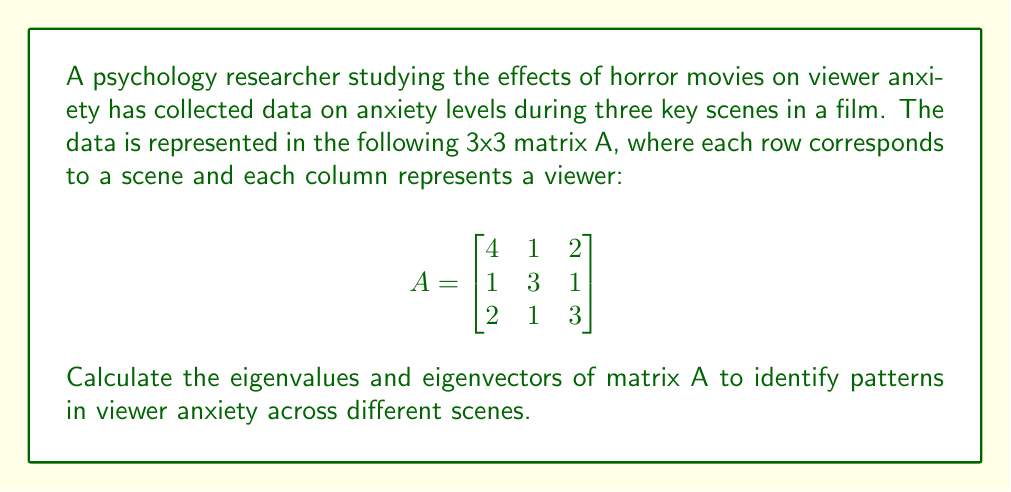Solve this math problem. To find the eigenvalues and eigenvectors of matrix A, we follow these steps:

1. Find the characteristic equation:
   $det(A - \lambda I) = 0$, where I is the 3x3 identity matrix.

   $$det\begin{pmatrix}
   4-\lambda & 1 & 2 \\
   1 & 3-\lambda & 1 \\
   2 & 1 & 3-\lambda
   \end{pmatrix} = 0$$

2. Expand the determinant:
   $(4-\lambda)[(3-\lambda)(3-\lambda)-1] - 1[1(3-\lambda)-2] + 2[1-1(3-\lambda)] = 0$
   $(4-\lambda)[(3-\lambda)^2-1] - [3-\lambda-2] + 2[1-(3-\lambda)] = 0$
   $(4-\lambda)(\lambda^2-6\lambda+8) + \lambda-1 - 2(4-\lambda) = 0$
   $4\lambda^2-24\lambda+32-\lambda^3+6\lambda^2-8\lambda+\lambda-1-8+2\lambda = 0$
   $-\lambda^3+10\lambda^2-29\lambda+23 = 0$

3. Solve the characteristic equation:
   The equation factors to: $(\lambda-1)(\lambda-3)(\lambda-6) = 0$
   So, the eigenvalues are $\lambda_1 = 1$, $\lambda_2 = 3$, and $\lambda_3 = 6$

4. Find the eigenvectors for each eigenvalue:
   For $\lambda_1 = 1$:
   Solve $(A-I)v = 0$
   $$\begin{bmatrix}
   3 & 1 & 2 \\
   1 & 2 & 1 \\
   2 & 1 & 2
   \end{bmatrix}\begin{bmatrix}
   v_1 \\ v_2 \\ v_3
   \end{bmatrix} = \begin{bmatrix}
   0 \\ 0 \\ 0
   \end{bmatrix}$$
   This gives us: $v_1 = -1$, $v_2 = 1$, $v_3 = -1$

   For $\lambda_2 = 3$:
   Solve $(A-3I)v = 0$
   $$\begin{bmatrix}
   1 & 1 & 2 \\
   1 & 0 & 1 \\
   2 & 1 & 0
   \end{bmatrix}\begin{bmatrix}
   v_1 \\ v_2 \\ v_3
   \end{bmatrix} = \begin{bmatrix}
   0 \\ 0 \\ 0
   \end{bmatrix}$$
   This gives us: $v_1 = 1$, $v_2 = -2$, $v_3 = 1$

   For $\lambda_3 = 6$:
   Solve $(A-6I)v = 0$
   $$\begin{bmatrix}
   -2 & 1 & 2 \\
   1 & -3 & 1 \\
   2 & 1 & -3
   \end{bmatrix}\begin{bmatrix}
   v_1 \\ v_2 \\ v_3
   \end{bmatrix} = \begin{bmatrix}
   0 \\ 0 \\ 0
   \end{bmatrix}$$
   This gives us: $v_1 = 2$, $v_2 = 1$, $v_3 = 2$
Answer: Eigenvalues: $\lambda_1 = 1$, $\lambda_2 = 3$, $\lambda_3 = 6$

Eigenvectors:
$v_1 = \begin{bmatrix} -1 \\ 1 \\ -1 \end{bmatrix}$, 
$v_2 = \begin{bmatrix} 1 \\ -2 \\ 1 \end{bmatrix}$, 
$v_3 = \begin{bmatrix} 2 \\ 1 \\ 2 \end{bmatrix}$ 